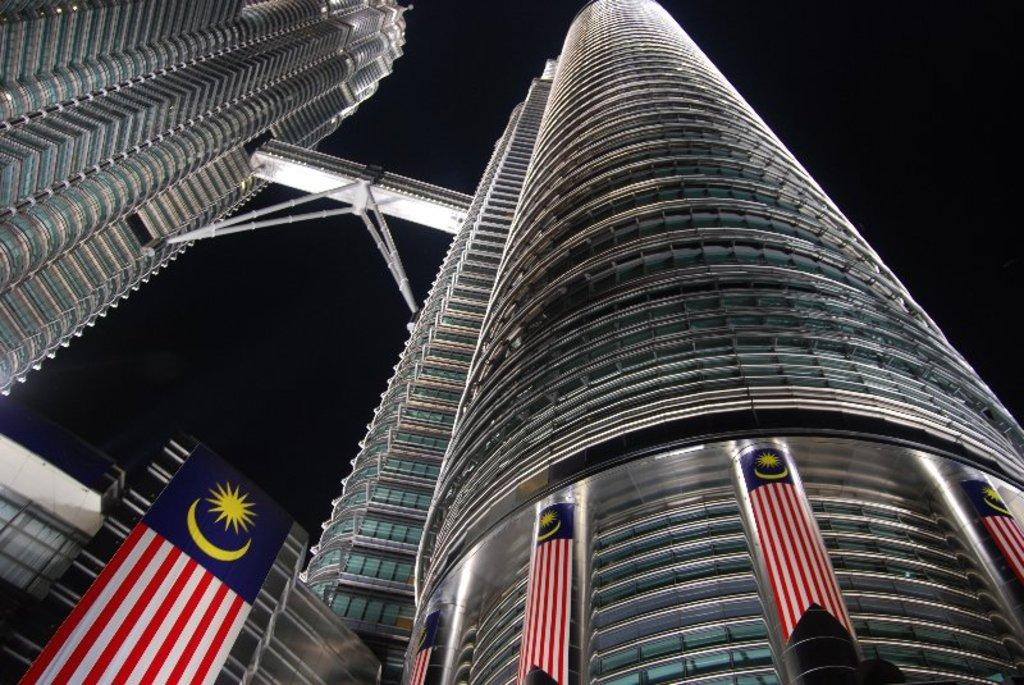Where was the picture taken? The picture was clicked outside. What can be seen in the center of the image? There are skyscrapers in the center of the image. What type of structures are present in the image? Metal rods and a bridge are present in the image. What else can be seen in the image? Flags are visible in the image. What is visible in the background of the image? The sky is visible in the background of the image. What type of fuel is being used by the vehicles on the bridge in the image? There are no vehicles visible in the image, so it is not possible to determine what type of fuel they might be using. 